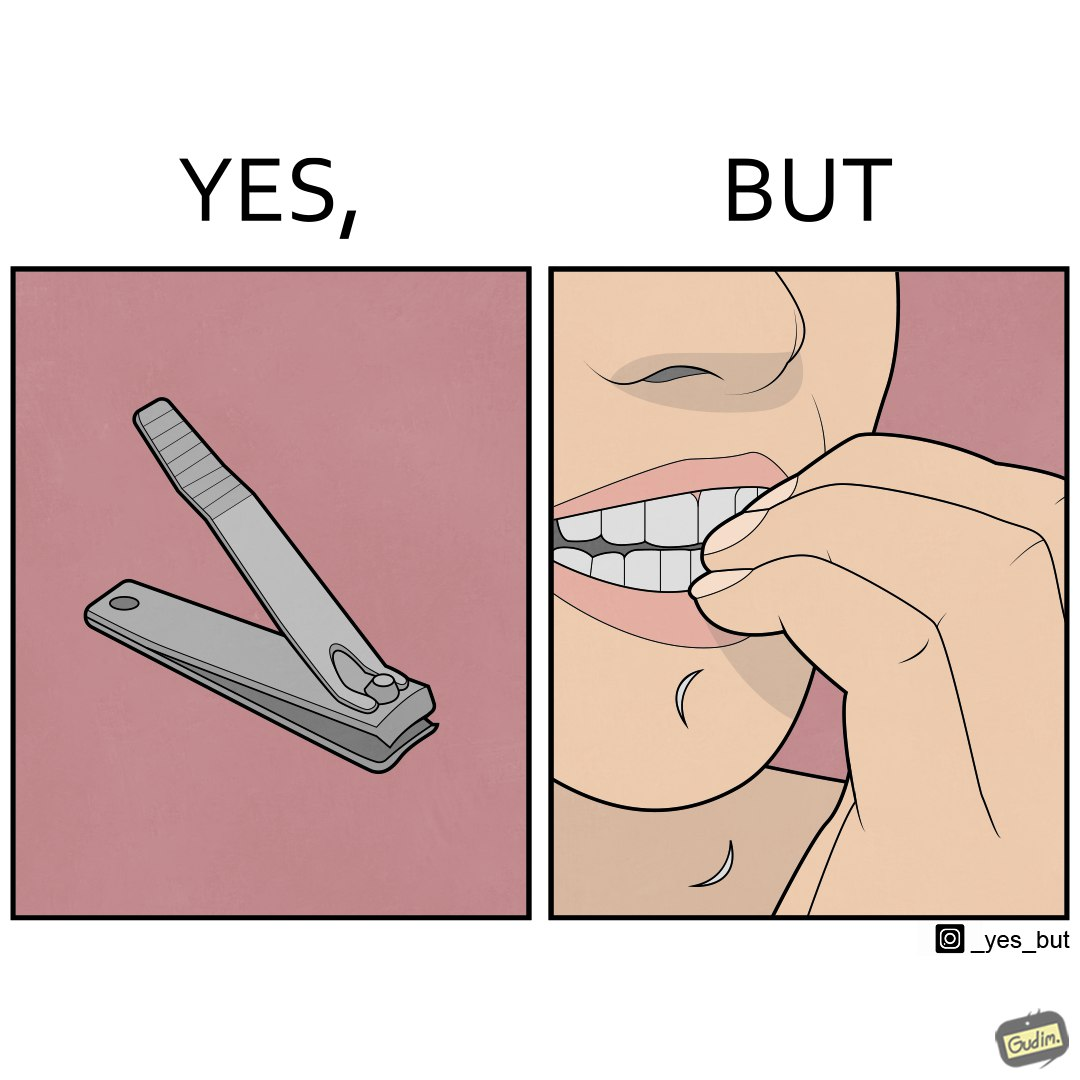What is shown in the left half versus the right half of this image? In the left part of the image: a nail clipper In the right part of the image: a person biting their nails to cut them 